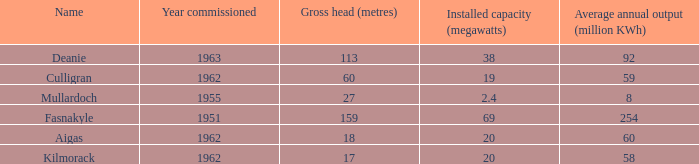What is the Year commissioned of the power station with a Gross head of 60 metres and Average annual output of less than 59 million KWh? None. 